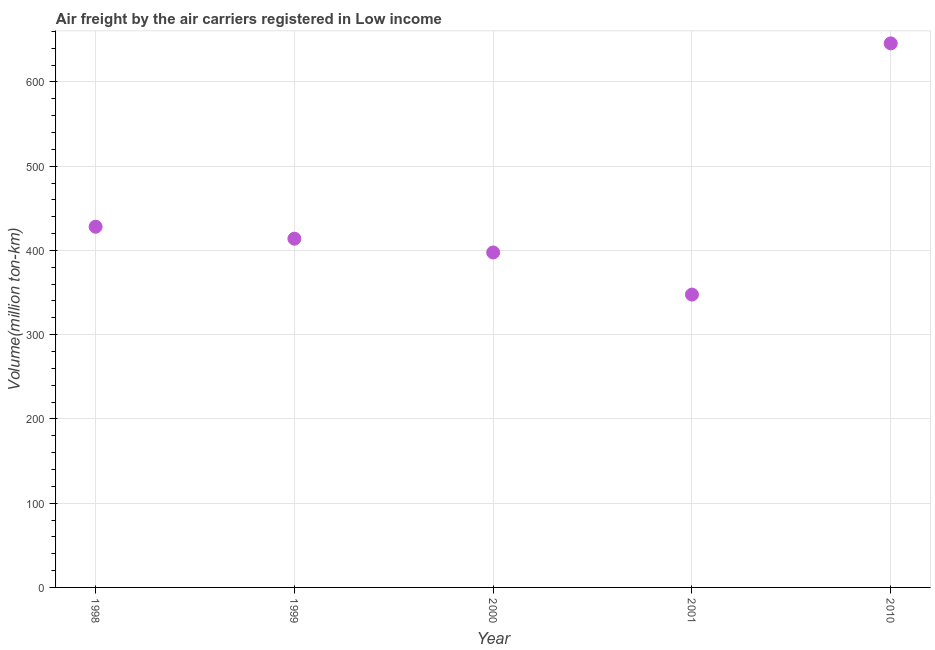What is the air freight in 1998?
Offer a terse response. 428.1. Across all years, what is the maximum air freight?
Keep it short and to the point. 645.72. Across all years, what is the minimum air freight?
Offer a terse response. 347.57. In which year was the air freight minimum?
Offer a very short reply. 2001. What is the sum of the air freight?
Your answer should be very brief. 2232.85. What is the difference between the air freight in 2001 and 2010?
Offer a very short reply. -298.15. What is the average air freight per year?
Your response must be concise. 446.57. What is the median air freight?
Make the answer very short. 413.9. Do a majority of the years between 2001 and 1998 (inclusive) have air freight greater than 100 million ton-km?
Offer a terse response. Yes. What is the ratio of the air freight in 1998 to that in 2001?
Ensure brevity in your answer.  1.23. Is the air freight in 1999 less than that in 2001?
Provide a short and direct response. No. Is the difference between the air freight in 2000 and 2010 greater than the difference between any two years?
Your response must be concise. No. What is the difference between the highest and the second highest air freight?
Keep it short and to the point. 217.62. What is the difference between the highest and the lowest air freight?
Provide a succinct answer. 298.15. In how many years, is the air freight greater than the average air freight taken over all years?
Your answer should be compact. 1. Does the air freight monotonically increase over the years?
Your answer should be compact. No. How many dotlines are there?
Your answer should be very brief. 1. What is the difference between two consecutive major ticks on the Y-axis?
Offer a very short reply. 100. Are the values on the major ticks of Y-axis written in scientific E-notation?
Your answer should be compact. No. Does the graph contain any zero values?
Ensure brevity in your answer.  No. Does the graph contain grids?
Your answer should be very brief. Yes. What is the title of the graph?
Offer a terse response. Air freight by the air carriers registered in Low income. What is the label or title of the Y-axis?
Your answer should be compact. Volume(million ton-km). What is the Volume(million ton-km) in 1998?
Keep it short and to the point. 428.1. What is the Volume(million ton-km) in 1999?
Offer a terse response. 413.9. What is the Volume(million ton-km) in 2000?
Your response must be concise. 397.56. What is the Volume(million ton-km) in 2001?
Provide a succinct answer. 347.57. What is the Volume(million ton-km) in 2010?
Make the answer very short. 645.72. What is the difference between the Volume(million ton-km) in 1998 and 1999?
Offer a terse response. 14.2. What is the difference between the Volume(million ton-km) in 1998 and 2000?
Make the answer very short. 30.54. What is the difference between the Volume(million ton-km) in 1998 and 2001?
Keep it short and to the point. 80.53. What is the difference between the Volume(million ton-km) in 1998 and 2010?
Your answer should be compact. -217.62. What is the difference between the Volume(million ton-km) in 1999 and 2000?
Give a very brief answer. 16.34. What is the difference between the Volume(million ton-km) in 1999 and 2001?
Ensure brevity in your answer.  66.33. What is the difference between the Volume(million ton-km) in 1999 and 2010?
Give a very brief answer. -231.82. What is the difference between the Volume(million ton-km) in 2000 and 2001?
Your answer should be compact. 50. What is the difference between the Volume(million ton-km) in 2000 and 2010?
Your response must be concise. -248.16. What is the difference between the Volume(million ton-km) in 2001 and 2010?
Provide a short and direct response. -298.15. What is the ratio of the Volume(million ton-km) in 1998 to that in 1999?
Provide a succinct answer. 1.03. What is the ratio of the Volume(million ton-km) in 1998 to that in 2000?
Give a very brief answer. 1.08. What is the ratio of the Volume(million ton-km) in 1998 to that in 2001?
Offer a very short reply. 1.23. What is the ratio of the Volume(million ton-km) in 1998 to that in 2010?
Make the answer very short. 0.66. What is the ratio of the Volume(million ton-km) in 1999 to that in 2000?
Your response must be concise. 1.04. What is the ratio of the Volume(million ton-km) in 1999 to that in 2001?
Provide a short and direct response. 1.19. What is the ratio of the Volume(million ton-km) in 1999 to that in 2010?
Keep it short and to the point. 0.64. What is the ratio of the Volume(million ton-km) in 2000 to that in 2001?
Your answer should be compact. 1.14. What is the ratio of the Volume(million ton-km) in 2000 to that in 2010?
Provide a short and direct response. 0.62. What is the ratio of the Volume(million ton-km) in 2001 to that in 2010?
Your answer should be very brief. 0.54. 